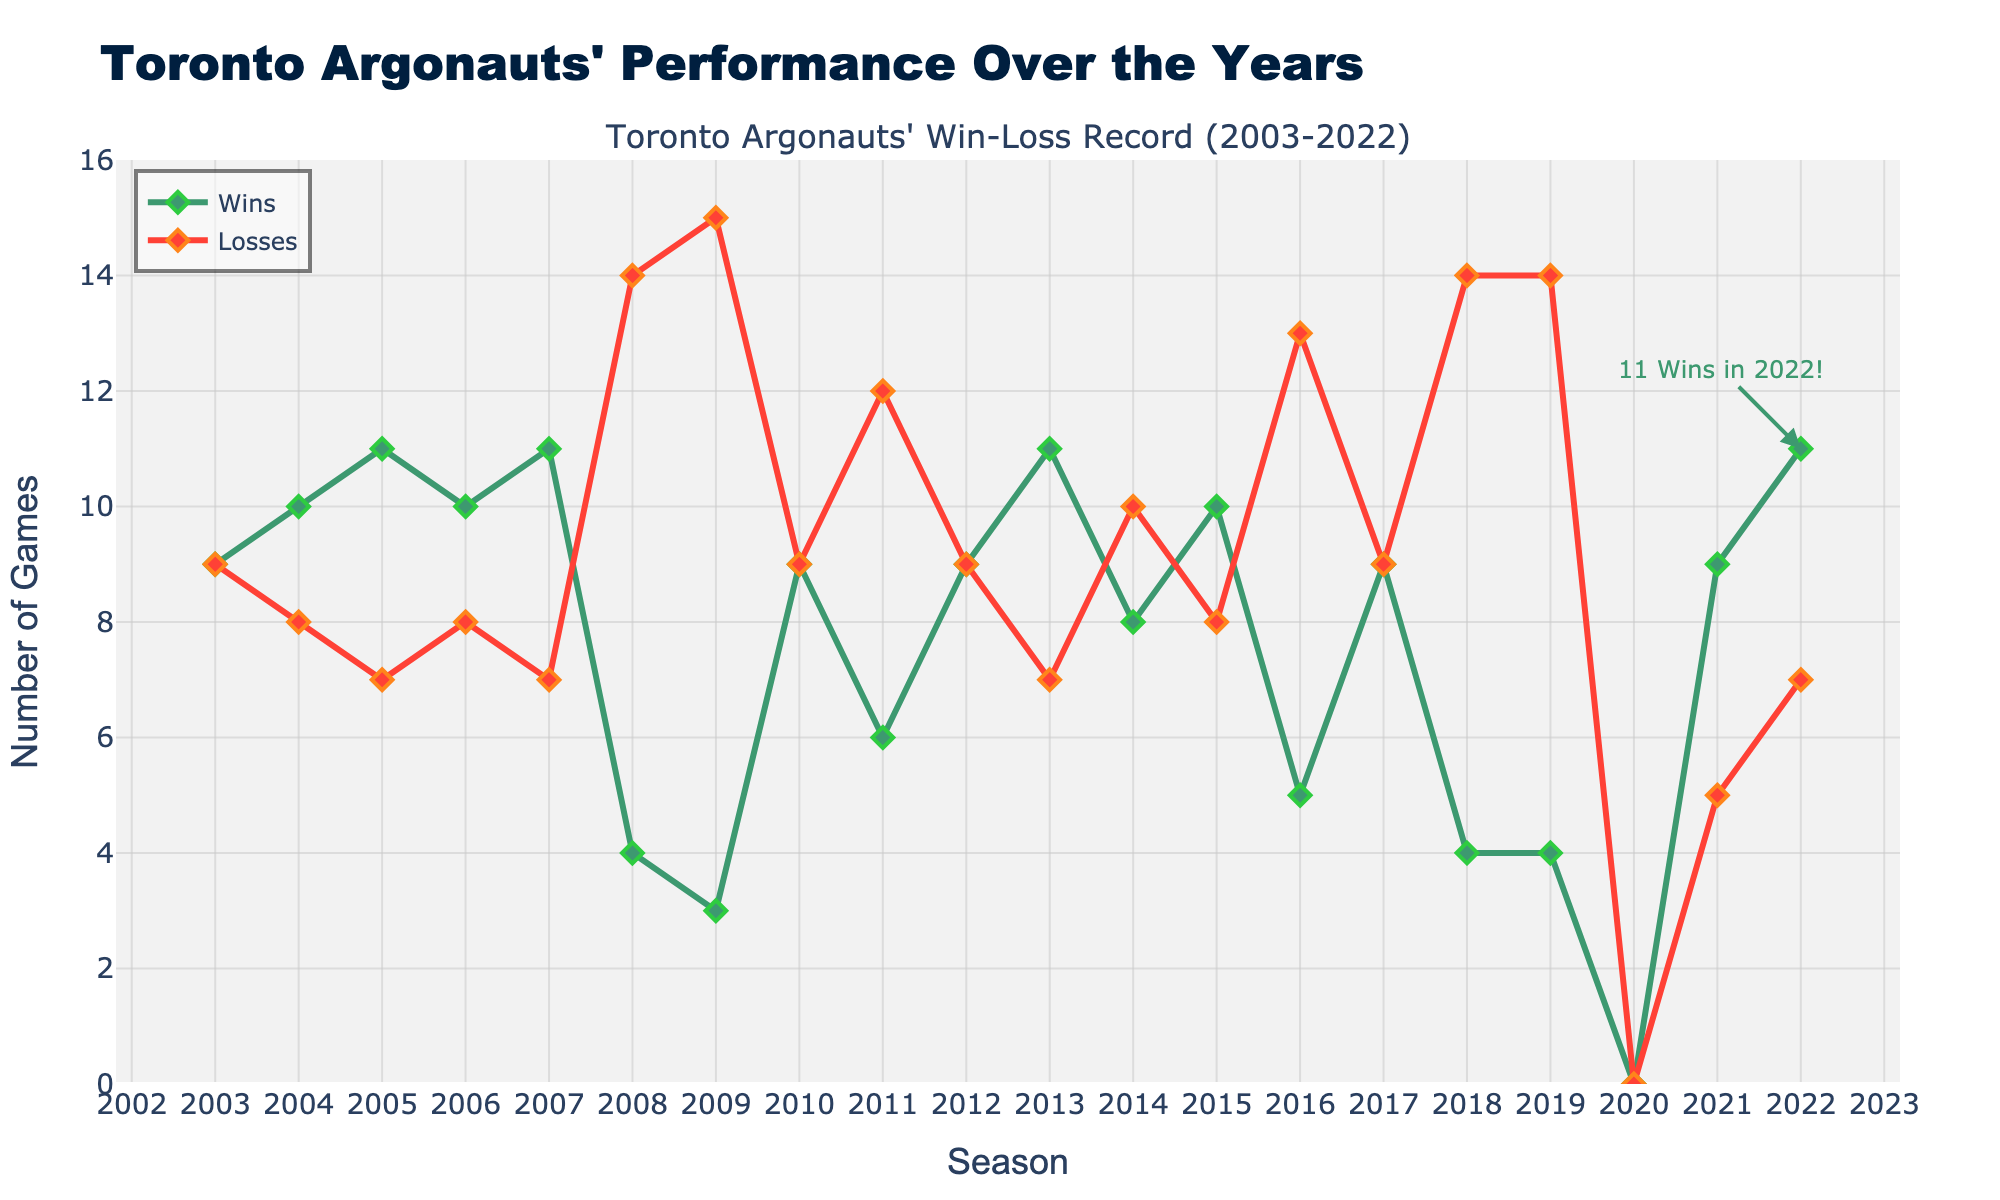How many seasons did the Toronto Argonauts have an equal number of wins and losses? Count the seasons where the number of wins is equal to the number of losses by looking at the data points for each season and checking for equality. The seasons 2003, 2010, 2012, and 2017 all have 9 wins and 9 losses.
Answer: 4 In which season did the Toronto Argonauts have the highest number of wins? Identify the peak value on the "Wins" line and note the corresponding season for that peak. The highest number of wins, 11, is achieved in multiple seasons: 2005, 2007, 2013, and 2022.
Answer: 2005, 2007, 2013, 2022 What is the average number of wins for the Toronto Argonauts from 2003 to 2022? Sum the number of wins over all seasons and divide by the total number of seasons. The sum of wins is 149, and there are 20 seasons. Thus, the average is 149/20 = 7.45.
Answer: 7.45 In which season did the Toronto Argonauts have the most losses, and how many were they? Look for the peak on the "Losses" line of the plot and identify the corresponding value and season. The peak for losses is 15, which occurred in both 2009 and 2019.
Answer: 2009, 2019, 15 How many seasons did the Toronto Argonauts have a winning record (>9 wins)? Count the seasons where the number of wins is greater than 9 by checking the data points. These seasons are 2005, 2007, 2013, 2015, and 2022.
Answer: 5 Which season experienced the largest number of losses relative to wins, and what was the difference? Check the difference between losses and wins for each season and identify the maximum difference. The season 2009 had 3 wins and 15 losses, resulting in the largest difference of 12.
Answer: 2009, 12 Describe the general trend in the win-loss record for the Toronto Argonauts from 2008 to 2019. Analyze the "Wins" and "Losses" lines within the specified range of seasons. A clear declining trend can be seen in Wins, with a few exceptions, leading to more seasons with high losses than wins.
Answer: Declining trend in wins, increasing trend in losses How many seasons did the Toronto Argonauts win fewer than 5 games? Count the seasons where the line for "Wins" is below 5. The seasons with fewer than 5 wins are 2008, 2009, 2016, 2018, and 2019.
Answer: 5 